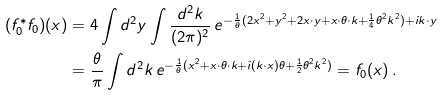<formula> <loc_0><loc_0><loc_500><loc_500>( f _ { 0 } ^ { * } f _ { 0 } ) ( x ) & = 4 \int d ^ { 2 } y \int \frac { d ^ { 2 } k } { ( 2 \pi ) ^ { 2 } } \, e ^ { - \frac { 1 } { \theta } ( 2 x ^ { 2 } + y ^ { 2 } + 2 x \cdot y + x \cdot \theta \cdot k + \frac { 1 } { 4 } \theta ^ { 2 } k ^ { 2 } ) + i k \cdot y } \\ & = \frac { \theta } { \pi } \int d ^ { 2 } k \, e ^ { - \frac { 1 } { \theta } ( x ^ { 2 } + x \cdot \theta \cdot k + i ( k \cdot x ) \theta + \frac { 1 } { 2 } \theta ^ { 2 } k ^ { 2 } ) } = f _ { 0 } ( x ) \, .</formula> 